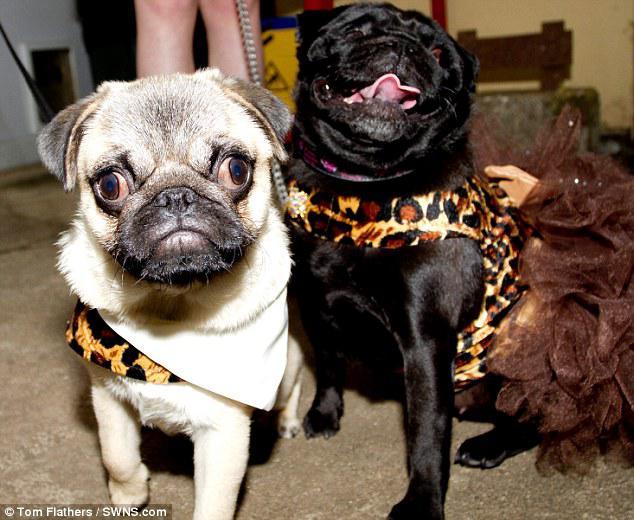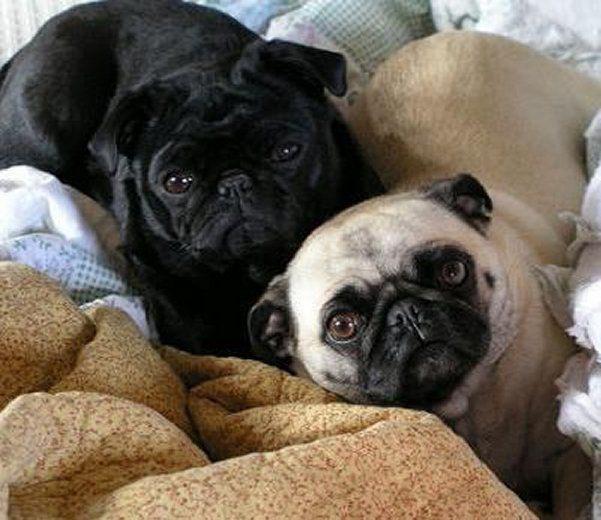The first image is the image on the left, the second image is the image on the right. For the images displayed, is the sentence "In one image in each pair at least one dog is in water." factually correct? Answer yes or no. No. The first image is the image on the left, the second image is the image on the right. For the images displayed, is the sentence "There are three dogs." factually correct? Answer yes or no. No. 